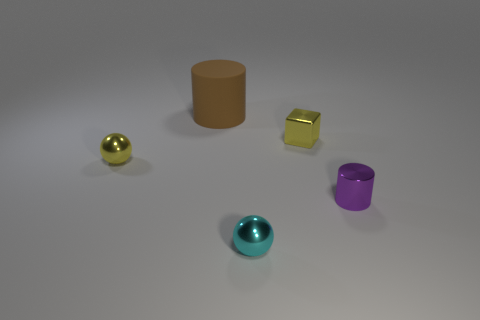Add 4 tiny yellow things. How many objects exist? 9 Subtract all balls. How many objects are left? 3 Add 2 yellow shiny cubes. How many yellow shiny cubes are left? 3 Add 5 tiny red spheres. How many tiny red spheres exist? 5 Subtract 1 cyan spheres. How many objects are left? 4 Subtract all tiny purple metallic cylinders. Subtract all large matte objects. How many objects are left? 3 